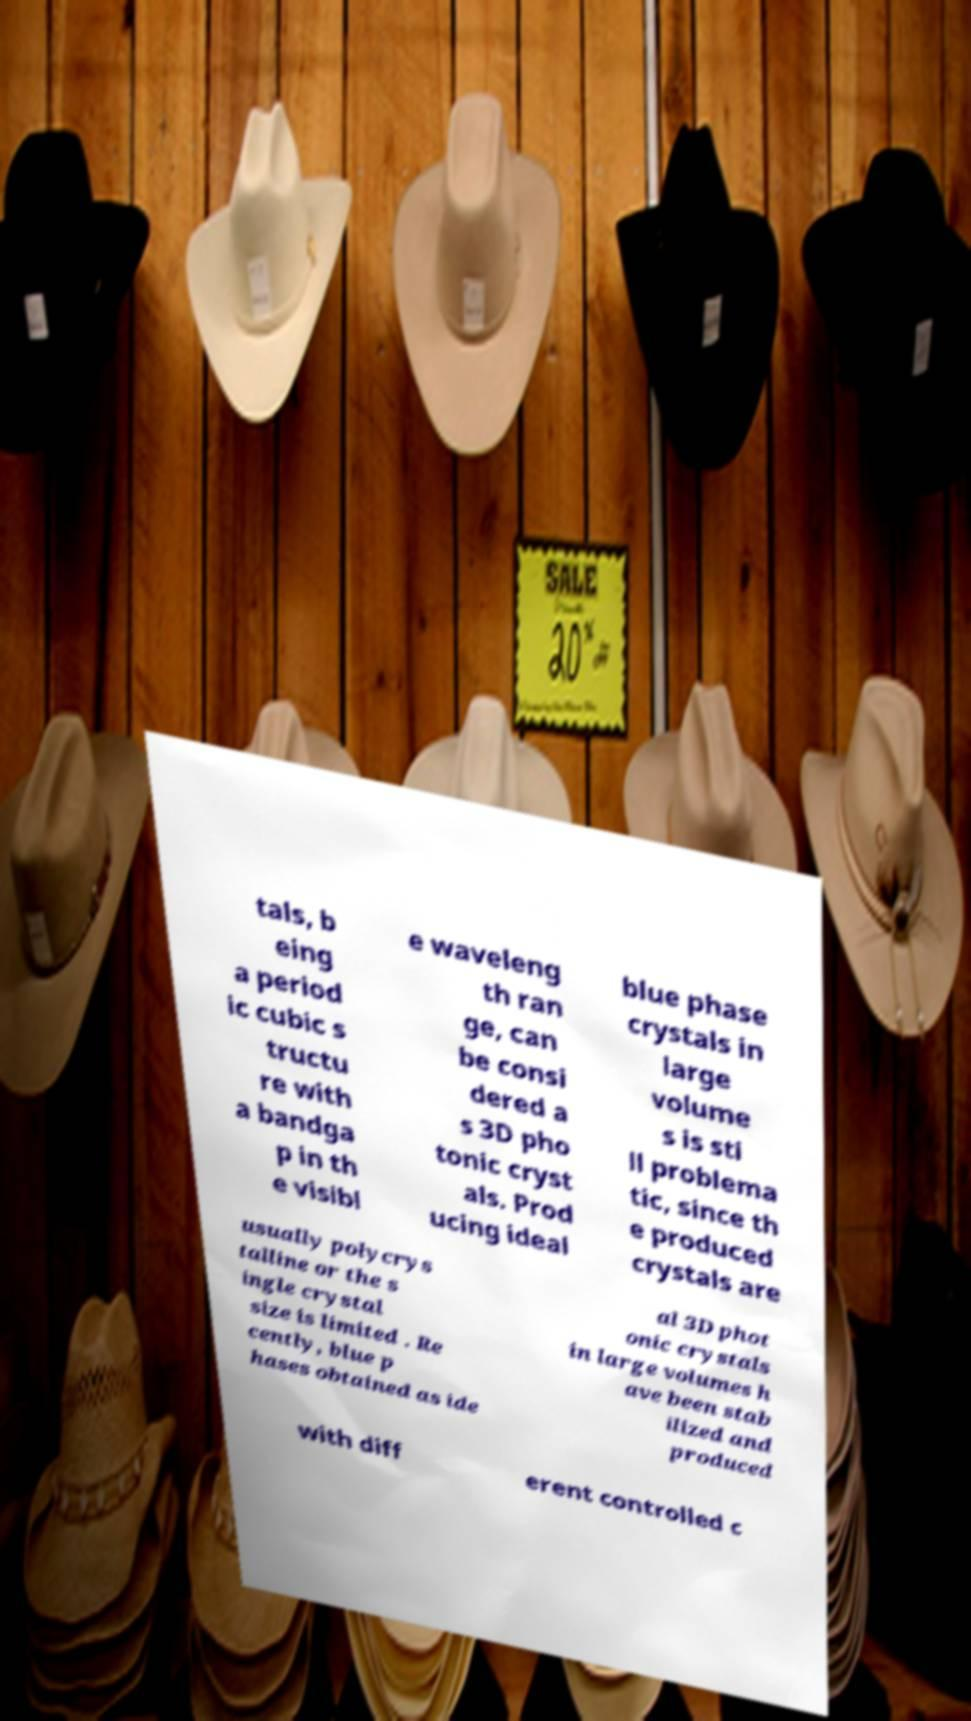What messages or text are displayed in this image? I need them in a readable, typed format. tals, b eing a period ic cubic s tructu re with a bandga p in th e visibl e waveleng th ran ge, can be consi dered a s 3D pho tonic cryst als. Prod ucing ideal blue phase crystals in large volume s is sti ll problema tic, since th e produced crystals are usually polycrys talline or the s ingle crystal size is limited . Re cently, blue p hases obtained as ide al 3D phot onic crystals in large volumes h ave been stab ilized and produced with diff erent controlled c 